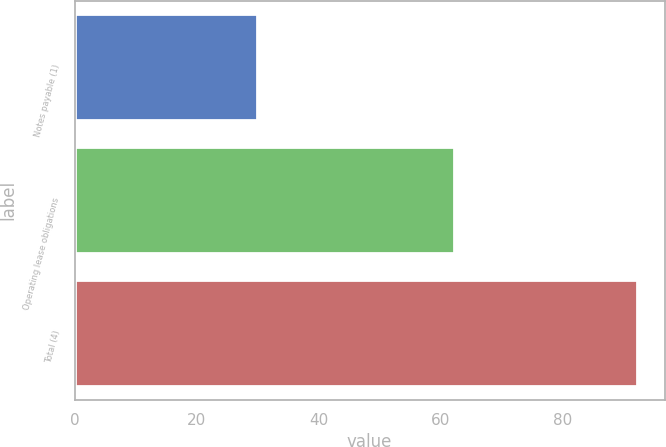<chart> <loc_0><loc_0><loc_500><loc_500><bar_chart><fcel>Notes payable (1)<fcel>Operating lease obligations<fcel>Total (4)<nl><fcel>29.9<fcel>62.2<fcel>92.2<nl></chart> 